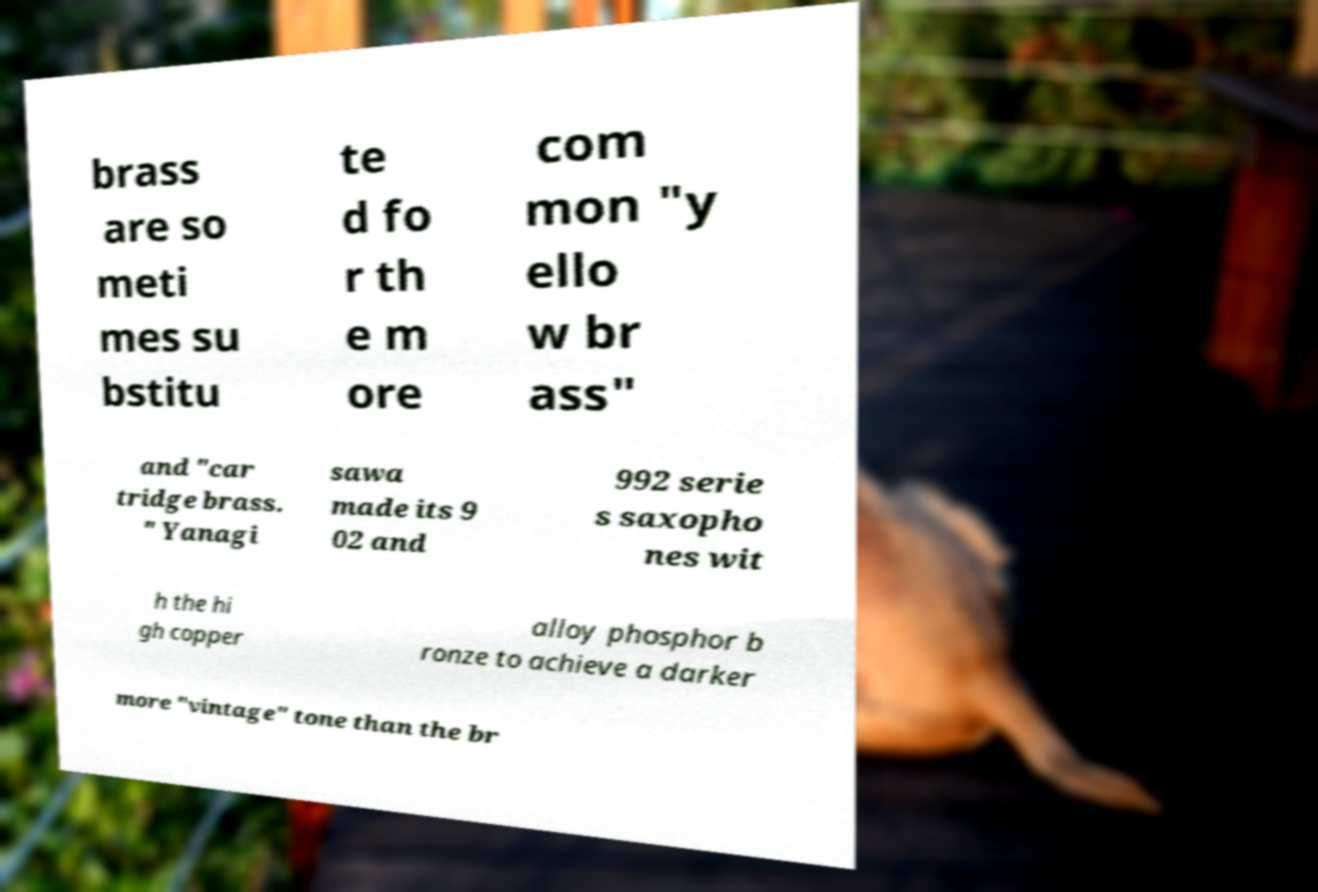Please identify and transcribe the text found in this image. brass are so meti mes su bstitu te d fo r th e m ore com mon "y ello w br ass" and "car tridge brass. " Yanagi sawa made its 9 02 and 992 serie s saxopho nes wit h the hi gh copper alloy phosphor b ronze to achieve a darker more "vintage" tone than the br 